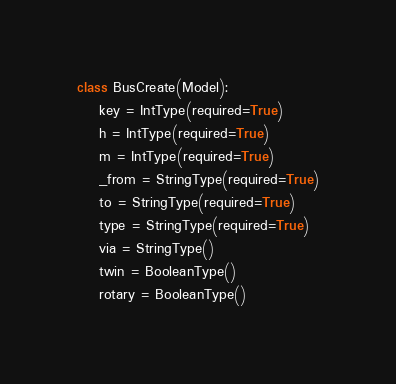<code> <loc_0><loc_0><loc_500><loc_500><_Python_>
class BusCreate(Model):
    key = IntType(required=True)
    h = IntType(required=True)
    m = IntType(required=True)
    _from = StringType(required=True)
    to = StringType(required=True)
    type = StringType(required=True)
    via = StringType()
    twin = BooleanType()
    rotary = BooleanType()
</code> 